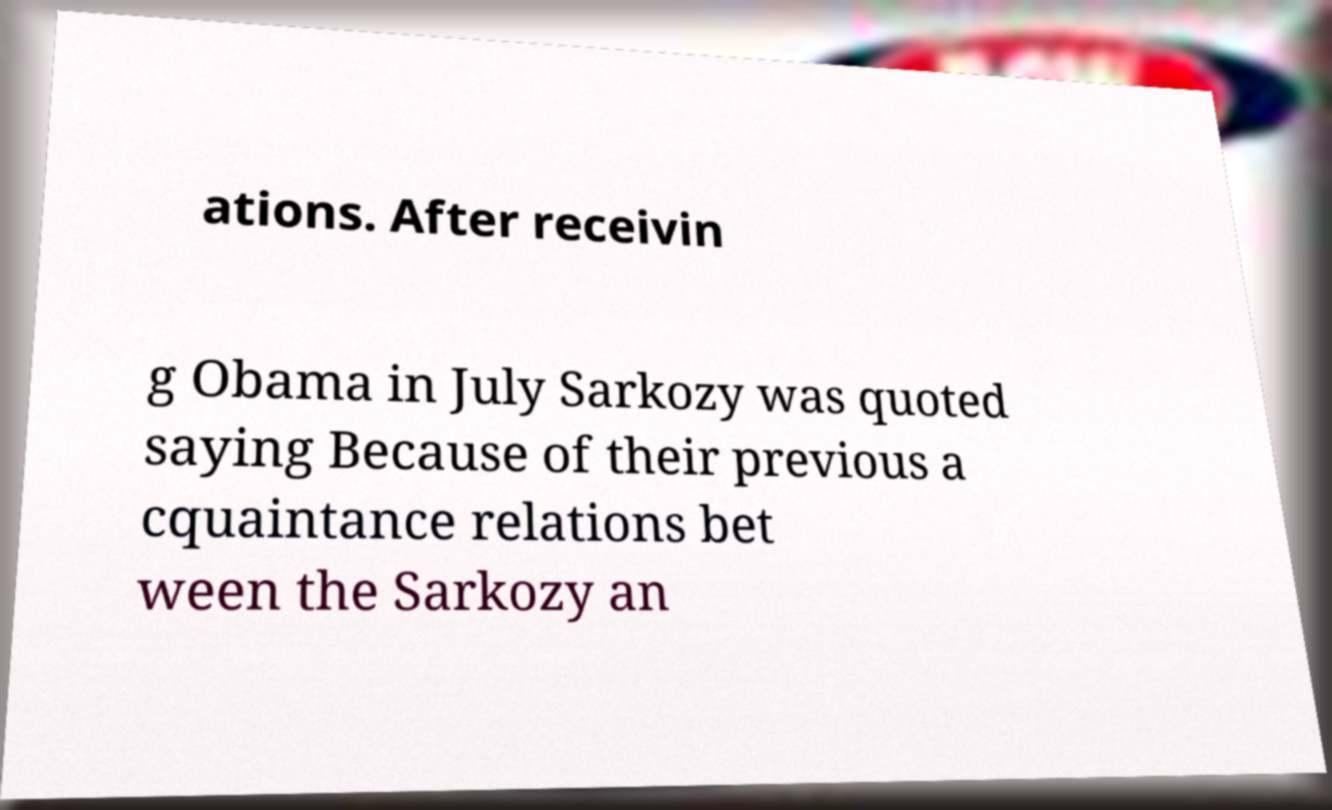Can you accurately transcribe the text from the provided image for me? ations. After receivin g Obama in July Sarkozy was quoted saying Because of their previous a cquaintance relations bet ween the Sarkozy an 